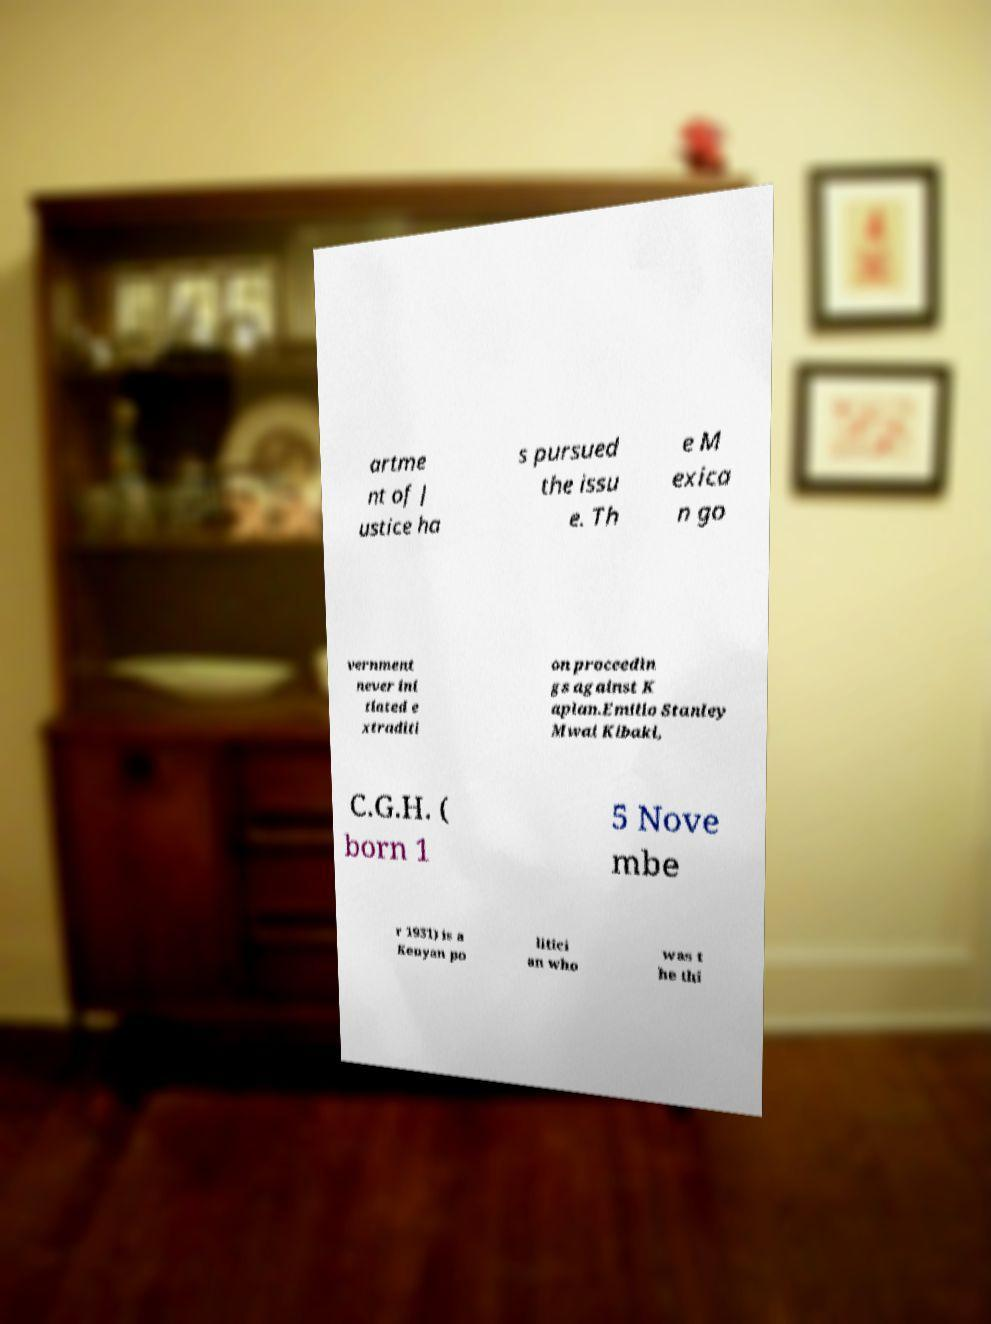Could you assist in decoding the text presented in this image and type it out clearly? artme nt of J ustice ha s pursued the issu e. Th e M exica n go vernment never ini tiated e xtraditi on proceedin gs against K aplan.Emilio Stanley Mwai Kibaki, C.G.H. ( born 1 5 Nove mbe r 1931) is a Kenyan po litici an who was t he thi 